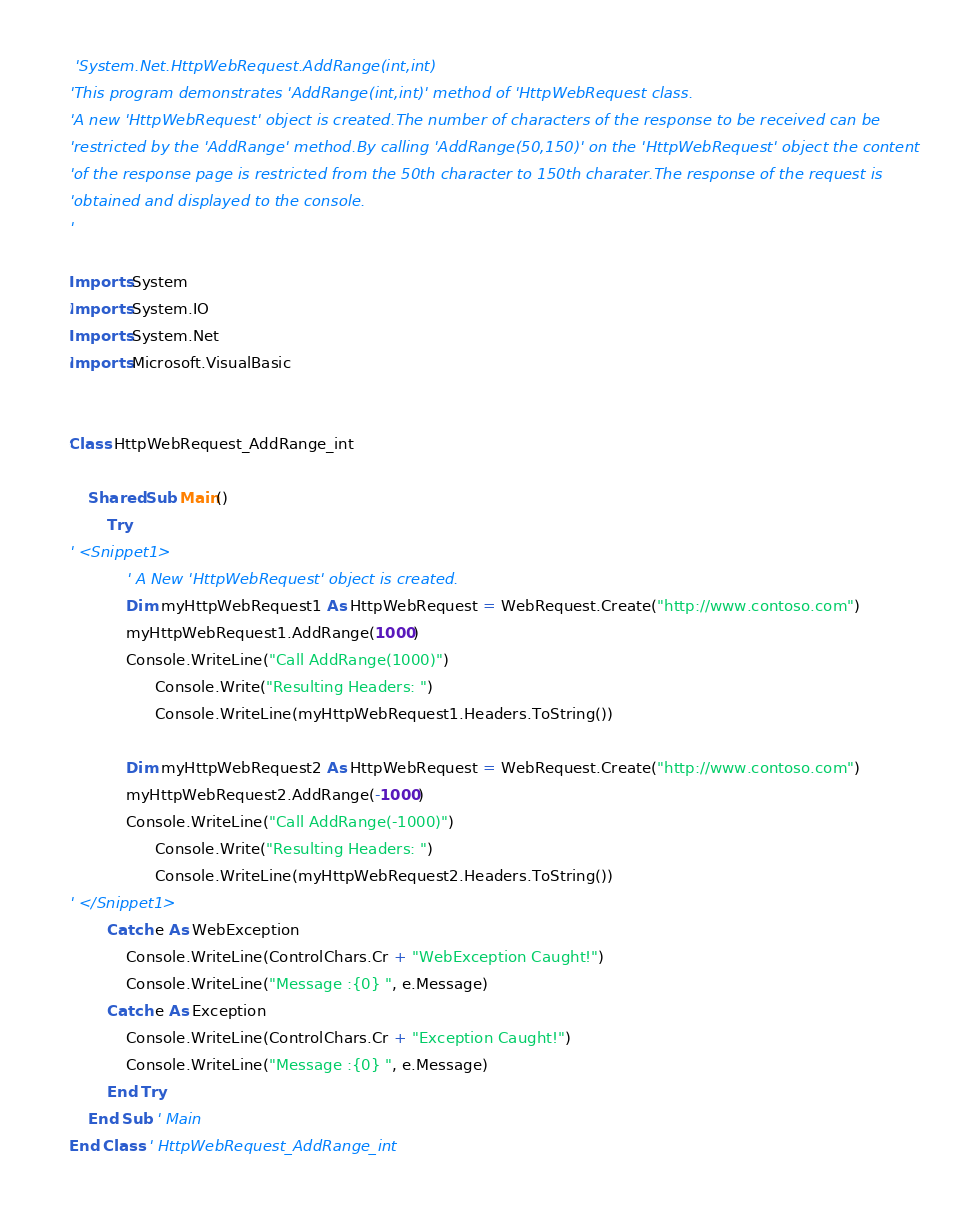<code> <loc_0><loc_0><loc_500><loc_500><_VisualBasic_> 'System.Net.HttpWebRequest.AddRange(int,int)
'This program demonstrates 'AddRange(int,int)' method of 'HttpWebRequest class.
'A new 'HttpWebRequest' object is created.The number of characters of the response to be received can be 
'restricted by the 'AddRange' method.By calling 'AddRange(50,150)' on the 'HttpWebRequest' object the content 
'of the response page is restricted from the 50th character to 150th charater.The response of the request is
'obtained and displayed to the console.
'

Imports System
Imports System.IO
Imports System.Net
Imports Microsoft.VisualBasic


Class HttpWebRequest_AddRange_int
    
    Shared Sub Main()
        Try
' <Snippet1>
            ' A New 'HttpWebRequest' object is created.
            Dim myHttpWebRequest1 As HttpWebRequest = WebRequest.Create("http://www.contoso.com")
            myHttpWebRequest1.AddRange(1000)
            Console.WriteLine("Call AddRange(1000)")
			      Console.Write("Resulting Headers: ")
			      Console.WriteLine(myHttpWebRequest1.Headers.ToString())

            Dim myHttpWebRequest2 As HttpWebRequest = WebRequest.Create("http://www.contoso.com")
            myHttpWebRequest2.AddRange(-1000)
            Console.WriteLine("Call AddRange(-1000)")
			      Console.Write("Resulting Headers: ")
			      Console.WriteLine(myHttpWebRequest2.Headers.ToString())
' </Snippet1>
        Catch e As WebException
            Console.WriteLine(ControlChars.Cr + "WebException Caught!")
            Console.WriteLine("Message :{0} ", e.Message)
        Catch e As Exception
            Console.WriteLine(ControlChars.Cr + "Exception Caught!")
            Console.WriteLine("Message :{0} ", e.Message)
        End Try
    End Sub ' Main
End Class ' HttpWebRequest_AddRange_int


</code> 